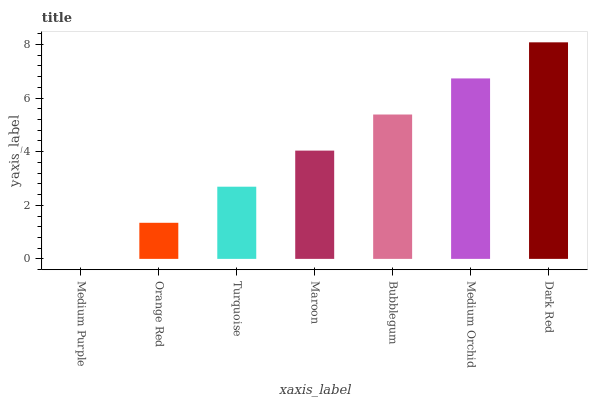Is Orange Red the minimum?
Answer yes or no. No. Is Orange Red the maximum?
Answer yes or no. No. Is Orange Red greater than Medium Purple?
Answer yes or no. Yes. Is Medium Purple less than Orange Red?
Answer yes or no. Yes. Is Medium Purple greater than Orange Red?
Answer yes or no. No. Is Orange Red less than Medium Purple?
Answer yes or no. No. Is Maroon the high median?
Answer yes or no. Yes. Is Maroon the low median?
Answer yes or no. Yes. Is Turquoise the high median?
Answer yes or no. No. Is Turquoise the low median?
Answer yes or no. No. 